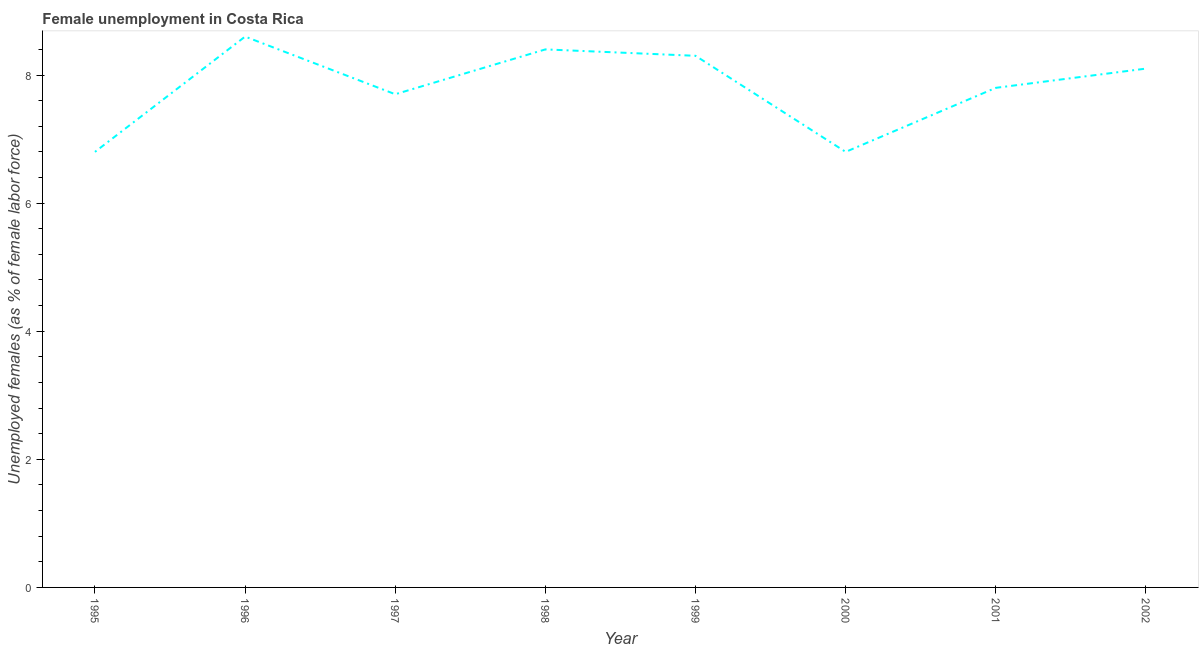What is the unemployed females population in 1997?
Provide a short and direct response. 7.7. Across all years, what is the maximum unemployed females population?
Provide a short and direct response. 8.6. Across all years, what is the minimum unemployed females population?
Ensure brevity in your answer.  6.8. In which year was the unemployed females population maximum?
Your response must be concise. 1996. What is the sum of the unemployed females population?
Provide a succinct answer. 62.5. What is the difference between the unemployed females population in 1998 and 2001?
Your answer should be very brief. 0.6. What is the average unemployed females population per year?
Your response must be concise. 7.81. What is the median unemployed females population?
Give a very brief answer. 7.95. What is the ratio of the unemployed females population in 1995 to that in 2001?
Offer a very short reply. 0.87. Is the unemployed females population in 1996 less than that in 2002?
Provide a succinct answer. No. What is the difference between the highest and the second highest unemployed females population?
Offer a terse response. 0.2. Is the sum of the unemployed females population in 1997 and 2001 greater than the maximum unemployed females population across all years?
Your response must be concise. Yes. What is the difference between the highest and the lowest unemployed females population?
Make the answer very short. 1.8. In how many years, is the unemployed females population greater than the average unemployed females population taken over all years?
Offer a very short reply. 4. How many lines are there?
Keep it short and to the point. 1. How many years are there in the graph?
Give a very brief answer. 8. What is the difference between two consecutive major ticks on the Y-axis?
Ensure brevity in your answer.  2. What is the title of the graph?
Make the answer very short. Female unemployment in Costa Rica. What is the label or title of the X-axis?
Your response must be concise. Year. What is the label or title of the Y-axis?
Your answer should be compact. Unemployed females (as % of female labor force). What is the Unemployed females (as % of female labor force) in 1995?
Ensure brevity in your answer.  6.8. What is the Unemployed females (as % of female labor force) of 1996?
Provide a succinct answer. 8.6. What is the Unemployed females (as % of female labor force) of 1997?
Keep it short and to the point. 7.7. What is the Unemployed females (as % of female labor force) of 1998?
Make the answer very short. 8.4. What is the Unemployed females (as % of female labor force) in 1999?
Offer a very short reply. 8.3. What is the Unemployed females (as % of female labor force) of 2000?
Your answer should be very brief. 6.8. What is the Unemployed females (as % of female labor force) of 2001?
Offer a terse response. 7.8. What is the Unemployed females (as % of female labor force) of 2002?
Offer a very short reply. 8.1. What is the difference between the Unemployed females (as % of female labor force) in 1995 and 1997?
Your response must be concise. -0.9. What is the difference between the Unemployed females (as % of female labor force) in 1995 and 1998?
Your answer should be compact. -1.6. What is the difference between the Unemployed females (as % of female labor force) in 1995 and 1999?
Give a very brief answer. -1.5. What is the difference between the Unemployed females (as % of female labor force) in 1995 and 2001?
Your answer should be compact. -1. What is the difference between the Unemployed females (as % of female labor force) in 1995 and 2002?
Your answer should be very brief. -1.3. What is the difference between the Unemployed females (as % of female labor force) in 1996 and 1998?
Your response must be concise. 0.2. What is the difference between the Unemployed females (as % of female labor force) in 1996 and 2002?
Give a very brief answer. 0.5. What is the difference between the Unemployed females (as % of female labor force) in 1997 and 1999?
Keep it short and to the point. -0.6. What is the difference between the Unemployed females (as % of female labor force) in 1997 and 2001?
Your response must be concise. -0.1. What is the difference between the Unemployed females (as % of female labor force) in 1997 and 2002?
Offer a very short reply. -0.4. What is the difference between the Unemployed females (as % of female labor force) in 1998 and 2001?
Your answer should be very brief. 0.6. What is the difference between the Unemployed females (as % of female labor force) in 1998 and 2002?
Your answer should be very brief. 0.3. What is the difference between the Unemployed females (as % of female labor force) in 1999 and 2001?
Keep it short and to the point. 0.5. What is the difference between the Unemployed females (as % of female labor force) in 1999 and 2002?
Make the answer very short. 0.2. What is the difference between the Unemployed females (as % of female labor force) in 2000 and 2001?
Provide a short and direct response. -1. What is the difference between the Unemployed females (as % of female labor force) in 2001 and 2002?
Your answer should be compact. -0.3. What is the ratio of the Unemployed females (as % of female labor force) in 1995 to that in 1996?
Your answer should be very brief. 0.79. What is the ratio of the Unemployed females (as % of female labor force) in 1995 to that in 1997?
Give a very brief answer. 0.88. What is the ratio of the Unemployed females (as % of female labor force) in 1995 to that in 1998?
Your answer should be compact. 0.81. What is the ratio of the Unemployed females (as % of female labor force) in 1995 to that in 1999?
Your answer should be compact. 0.82. What is the ratio of the Unemployed females (as % of female labor force) in 1995 to that in 2000?
Provide a succinct answer. 1. What is the ratio of the Unemployed females (as % of female labor force) in 1995 to that in 2001?
Ensure brevity in your answer.  0.87. What is the ratio of the Unemployed females (as % of female labor force) in 1995 to that in 2002?
Offer a terse response. 0.84. What is the ratio of the Unemployed females (as % of female labor force) in 1996 to that in 1997?
Your response must be concise. 1.12. What is the ratio of the Unemployed females (as % of female labor force) in 1996 to that in 1999?
Your answer should be compact. 1.04. What is the ratio of the Unemployed females (as % of female labor force) in 1996 to that in 2000?
Your answer should be very brief. 1.26. What is the ratio of the Unemployed females (as % of female labor force) in 1996 to that in 2001?
Keep it short and to the point. 1.1. What is the ratio of the Unemployed females (as % of female labor force) in 1996 to that in 2002?
Your response must be concise. 1.06. What is the ratio of the Unemployed females (as % of female labor force) in 1997 to that in 1998?
Your answer should be compact. 0.92. What is the ratio of the Unemployed females (as % of female labor force) in 1997 to that in 1999?
Offer a very short reply. 0.93. What is the ratio of the Unemployed females (as % of female labor force) in 1997 to that in 2000?
Your answer should be compact. 1.13. What is the ratio of the Unemployed females (as % of female labor force) in 1997 to that in 2002?
Provide a short and direct response. 0.95. What is the ratio of the Unemployed females (as % of female labor force) in 1998 to that in 1999?
Offer a very short reply. 1.01. What is the ratio of the Unemployed females (as % of female labor force) in 1998 to that in 2000?
Your answer should be very brief. 1.24. What is the ratio of the Unemployed females (as % of female labor force) in 1998 to that in 2001?
Make the answer very short. 1.08. What is the ratio of the Unemployed females (as % of female labor force) in 1998 to that in 2002?
Ensure brevity in your answer.  1.04. What is the ratio of the Unemployed females (as % of female labor force) in 1999 to that in 2000?
Offer a terse response. 1.22. What is the ratio of the Unemployed females (as % of female labor force) in 1999 to that in 2001?
Provide a short and direct response. 1.06. What is the ratio of the Unemployed females (as % of female labor force) in 2000 to that in 2001?
Your response must be concise. 0.87. What is the ratio of the Unemployed females (as % of female labor force) in 2000 to that in 2002?
Offer a terse response. 0.84. 